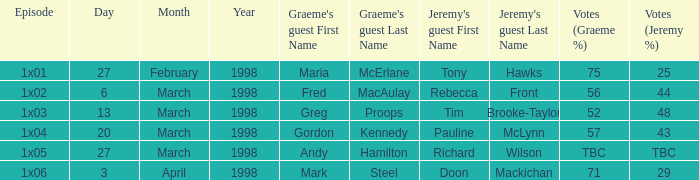What is Votes (%), when Episode is "1x03"? 52–48. 